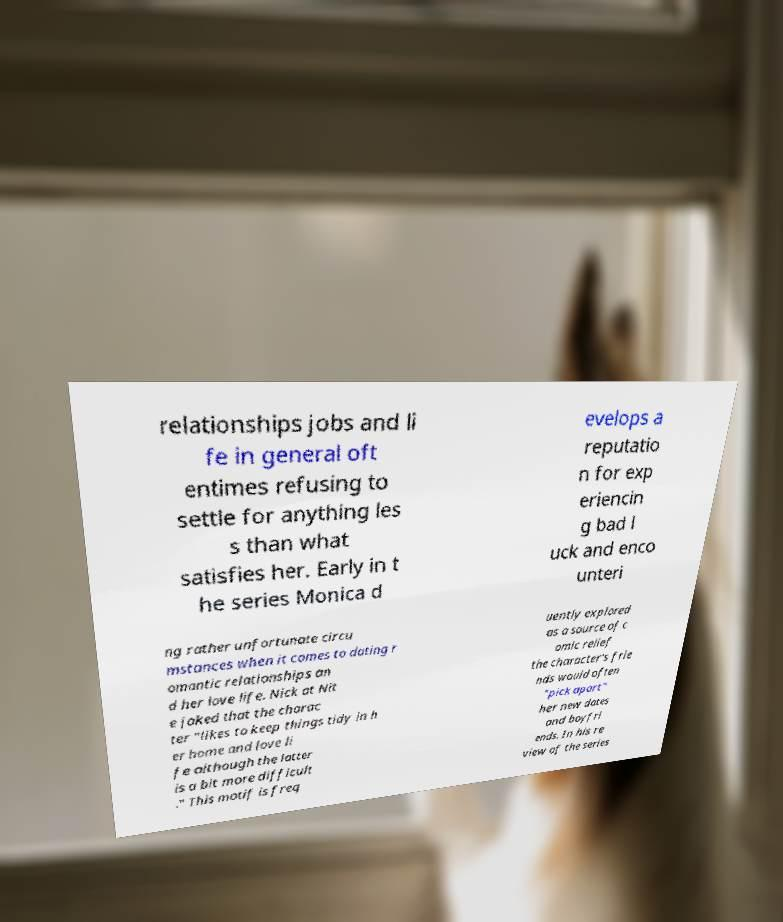Could you assist in decoding the text presented in this image and type it out clearly? relationships jobs and li fe in general oft entimes refusing to settle for anything les s than what satisfies her. Early in t he series Monica d evelops a reputatio n for exp eriencin g bad l uck and enco unteri ng rather unfortunate circu mstances when it comes to dating r omantic relationships an d her love life. Nick at Nit e joked that the charac ter "likes to keep things tidy in h er home and love li fe although the latter is a bit more difficult ." This motif is freq uently explored as a source of c omic relief the character's frie nds would often "pick apart" her new dates and boyfri ends. In his re view of the series 